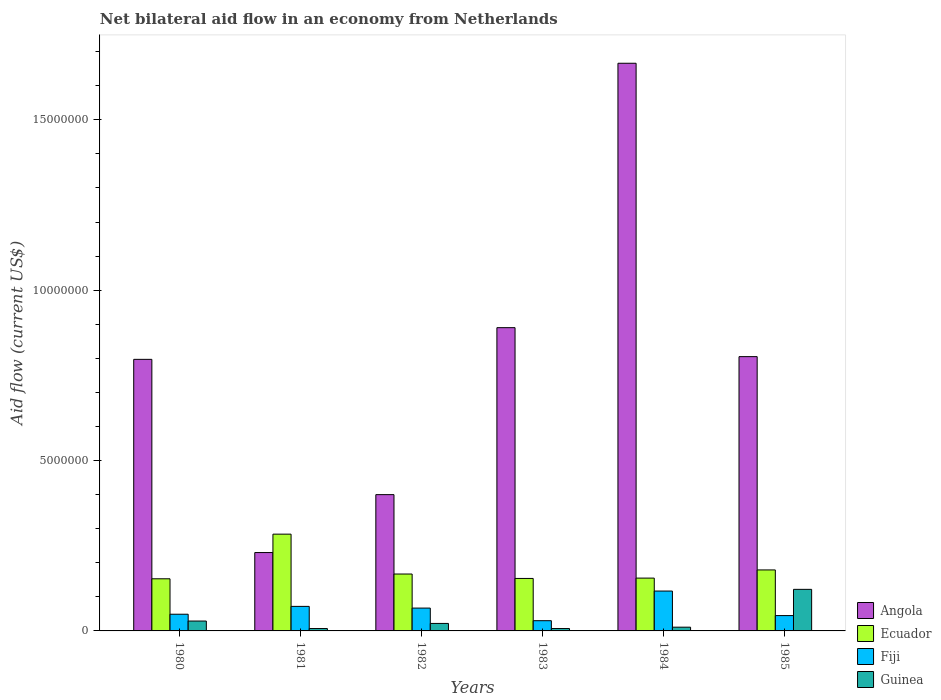Are the number of bars per tick equal to the number of legend labels?
Make the answer very short. Yes. How many bars are there on the 1st tick from the left?
Offer a very short reply. 4. What is the label of the 1st group of bars from the left?
Provide a succinct answer. 1980. Across all years, what is the maximum net bilateral aid flow in Angola?
Offer a terse response. 1.67e+07. Across all years, what is the minimum net bilateral aid flow in Ecuador?
Offer a very short reply. 1.53e+06. In which year was the net bilateral aid flow in Angola maximum?
Offer a terse response. 1984. In which year was the net bilateral aid flow in Angola minimum?
Keep it short and to the point. 1981. What is the total net bilateral aid flow in Fiji in the graph?
Your response must be concise. 3.80e+06. What is the difference between the net bilateral aid flow in Fiji in 1982 and the net bilateral aid flow in Ecuador in 1985?
Offer a very short reply. -1.12e+06. What is the average net bilateral aid flow in Guinea per year?
Ensure brevity in your answer.  3.30e+05. In the year 1980, what is the difference between the net bilateral aid flow in Angola and net bilateral aid flow in Fiji?
Make the answer very short. 7.48e+06. What is the ratio of the net bilateral aid flow in Guinea in 1980 to that in 1985?
Your answer should be compact. 0.24. Is the net bilateral aid flow in Fiji in 1982 less than that in 1985?
Give a very brief answer. No. What is the difference between the highest and the second highest net bilateral aid flow in Guinea?
Give a very brief answer. 9.30e+05. What is the difference between the highest and the lowest net bilateral aid flow in Guinea?
Your response must be concise. 1.15e+06. In how many years, is the net bilateral aid flow in Ecuador greater than the average net bilateral aid flow in Ecuador taken over all years?
Give a very brief answer. 1. Is the sum of the net bilateral aid flow in Guinea in 1982 and 1983 greater than the maximum net bilateral aid flow in Angola across all years?
Keep it short and to the point. No. What does the 3rd bar from the left in 1985 represents?
Give a very brief answer. Fiji. What does the 3rd bar from the right in 1980 represents?
Your response must be concise. Ecuador. Is it the case that in every year, the sum of the net bilateral aid flow in Fiji and net bilateral aid flow in Ecuador is greater than the net bilateral aid flow in Guinea?
Keep it short and to the point. Yes. Are all the bars in the graph horizontal?
Give a very brief answer. No. What is the difference between two consecutive major ticks on the Y-axis?
Make the answer very short. 5.00e+06. How many legend labels are there?
Ensure brevity in your answer.  4. How are the legend labels stacked?
Provide a succinct answer. Vertical. What is the title of the graph?
Offer a terse response. Net bilateral aid flow in an economy from Netherlands. Does "Mongolia" appear as one of the legend labels in the graph?
Keep it short and to the point. No. What is the label or title of the X-axis?
Make the answer very short. Years. What is the Aid flow (current US$) of Angola in 1980?
Give a very brief answer. 7.97e+06. What is the Aid flow (current US$) of Ecuador in 1980?
Offer a terse response. 1.53e+06. What is the Aid flow (current US$) in Fiji in 1980?
Provide a succinct answer. 4.90e+05. What is the Aid flow (current US$) of Guinea in 1980?
Your response must be concise. 2.90e+05. What is the Aid flow (current US$) of Angola in 1981?
Provide a succinct answer. 2.30e+06. What is the Aid flow (current US$) of Ecuador in 1981?
Ensure brevity in your answer.  2.84e+06. What is the Aid flow (current US$) of Fiji in 1981?
Offer a terse response. 7.20e+05. What is the Aid flow (current US$) in Ecuador in 1982?
Give a very brief answer. 1.67e+06. What is the Aid flow (current US$) of Fiji in 1982?
Your answer should be compact. 6.70e+05. What is the Aid flow (current US$) of Angola in 1983?
Provide a short and direct response. 8.90e+06. What is the Aid flow (current US$) of Ecuador in 1983?
Make the answer very short. 1.54e+06. What is the Aid flow (current US$) in Angola in 1984?
Provide a short and direct response. 1.67e+07. What is the Aid flow (current US$) of Ecuador in 1984?
Offer a very short reply. 1.55e+06. What is the Aid flow (current US$) of Fiji in 1984?
Ensure brevity in your answer.  1.17e+06. What is the Aid flow (current US$) in Angola in 1985?
Keep it short and to the point. 8.05e+06. What is the Aid flow (current US$) in Ecuador in 1985?
Offer a very short reply. 1.79e+06. What is the Aid flow (current US$) of Guinea in 1985?
Your answer should be compact. 1.22e+06. Across all years, what is the maximum Aid flow (current US$) in Angola?
Provide a succinct answer. 1.67e+07. Across all years, what is the maximum Aid flow (current US$) in Ecuador?
Offer a very short reply. 2.84e+06. Across all years, what is the maximum Aid flow (current US$) in Fiji?
Your answer should be compact. 1.17e+06. Across all years, what is the maximum Aid flow (current US$) in Guinea?
Ensure brevity in your answer.  1.22e+06. Across all years, what is the minimum Aid flow (current US$) of Angola?
Make the answer very short. 2.30e+06. Across all years, what is the minimum Aid flow (current US$) of Ecuador?
Provide a short and direct response. 1.53e+06. What is the total Aid flow (current US$) in Angola in the graph?
Offer a very short reply. 4.79e+07. What is the total Aid flow (current US$) of Ecuador in the graph?
Ensure brevity in your answer.  1.09e+07. What is the total Aid flow (current US$) of Fiji in the graph?
Keep it short and to the point. 3.80e+06. What is the total Aid flow (current US$) of Guinea in the graph?
Provide a short and direct response. 1.98e+06. What is the difference between the Aid flow (current US$) in Angola in 1980 and that in 1981?
Offer a terse response. 5.67e+06. What is the difference between the Aid flow (current US$) of Ecuador in 1980 and that in 1981?
Provide a short and direct response. -1.31e+06. What is the difference between the Aid flow (current US$) in Angola in 1980 and that in 1982?
Keep it short and to the point. 3.97e+06. What is the difference between the Aid flow (current US$) in Ecuador in 1980 and that in 1982?
Offer a very short reply. -1.40e+05. What is the difference between the Aid flow (current US$) of Fiji in 1980 and that in 1982?
Your answer should be compact. -1.80e+05. What is the difference between the Aid flow (current US$) in Guinea in 1980 and that in 1982?
Keep it short and to the point. 7.00e+04. What is the difference between the Aid flow (current US$) in Angola in 1980 and that in 1983?
Keep it short and to the point. -9.30e+05. What is the difference between the Aid flow (current US$) in Ecuador in 1980 and that in 1983?
Offer a terse response. -10000. What is the difference between the Aid flow (current US$) of Fiji in 1980 and that in 1983?
Offer a very short reply. 1.90e+05. What is the difference between the Aid flow (current US$) of Angola in 1980 and that in 1984?
Offer a very short reply. -8.69e+06. What is the difference between the Aid flow (current US$) in Fiji in 1980 and that in 1984?
Keep it short and to the point. -6.80e+05. What is the difference between the Aid flow (current US$) of Guinea in 1980 and that in 1985?
Keep it short and to the point. -9.30e+05. What is the difference between the Aid flow (current US$) in Angola in 1981 and that in 1982?
Ensure brevity in your answer.  -1.70e+06. What is the difference between the Aid flow (current US$) of Ecuador in 1981 and that in 1982?
Your response must be concise. 1.17e+06. What is the difference between the Aid flow (current US$) in Fiji in 1981 and that in 1982?
Ensure brevity in your answer.  5.00e+04. What is the difference between the Aid flow (current US$) of Guinea in 1981 and that in 1982?
Keep it short and to the point. -1.50e+05. What is the difference between the Aid flow (current US$) of Angola in 1981 and that in 1983?
Provide a short and direct response. -6.60e+06. What is the difference between the Aid flow (current US$) of Ecuador in 1981 and that in 1983?
Your answer should be compact. 1.30e+06. What is the difference between the Aid flow (current US$) in Guinea in 1981 and that in 1983?
Your response must be concise. 0. What is the difference between the Aid flow (current US$) of Angola in 1981 and that in 1984?
Offer a very short reply. -1.44e+07. What is the difference between the Aid flow (current US$) of Ecuador in 1981 and that in 1984?
Your answer should be very brief. 1.29e+06. What is the difference between the Aid flow (current US$) of Fiji in 1981 and that in 1984?
Your answer should be compact. -4.50e+05. What is the difference between the Aid flow (current US$) of Guinea in 1981 and that in 1984?
Provide a short and direct response. -4.00e+04. What is the difference between the Aid flow (current US$) of Angola in 1981 and that in 1985?
Offer a very short reply. -5.75e+06. What is the difference between the Aid flow (current US$) in Ecuador in 1981 and that in 1985?
Make the answer very short. 1.05e+06. What is the difference between the Aid flow (current US$) in Fiji in 1981 and that in 1985?
Ensure brevity in your answer.  2.70e+05. What is the difference between the Aid flow (current US$) of Guinea in 1981 and that in 1985?
Ensure brevity in your answer.  -1.15e+06. What is the difference between the Aid flow (current US$) of Angola in 1982 and that in 1983?
Your answer should be compact. -4.90e+06. What is the difference between the Aid flow (current US$) in Angola in 1982 and that in 1984?
Offer a very short reply. -1.27e+07. What is the difference between the Aid flow (current US$) in Ecuador in 1982 and that in 1984?
Your answer should be very brief. 1.20e+05. What is the difference between the Aid flow (current US$) of Fiji in 1982 and that in 1984?
Offer a terse response. -5.00e+05. What is the difference between the Aid flow (current US$) in Guinea in 1982 and that in 1984?
Keep it short and to the point. 1.10e+05. What is the difference between the Aid flow (current US$) of Angola in 1982 and that in 1985?
Provide a succinct answer. -4.05e+06. What is the difference between the Aid flow (current US$) in Ecuador in 1982 and that in 1985?
Offer a very short reply. -1.20e+05. What is the difference between the Aid flow (current US$) of Fiji in 1982 and that in 1985?
Your answer should be very brief. 2.20e+05. What is the difference between the Aid flow (current US$) of Guinea in 1982 and that in 1985?
Your answer should be compact. -1.00e+06. What is the difference between the Aid flow (current US$) in Angola in 1983 and that in 1984?
Give a very brief answer. -7.76e+06. What is the difference between the Aid flow (current US$) in Ecuador in 1983 and that in 1984?
Provide a short and direct response. -10000. What is the difference between the Aid flow (current US$) in Fiji in 1983 and that in 1984?
Keep it short and to the point. -8.70e+05. What is the difference between the Aid flow (current US$) in Angola in 1983 and that in 1985?
Offer a very short reply. 8.50e+05. What is the difference between the Aid flow (current US$) of Ecuador in 1983 and that in 1985?
Keep it short and to the point. -2.50e+05. What is the difference between the Aid flow (current US$) in Guinea in 1983 and that in 1985?
Offer a terse response. -1.15e+06. What is the difference between the Aid flow (current US$) of Angola in 1984 and that in 1985?
Your answer should be very brief. 8.61e+06. What is the difference between the Aid flow (current US$) of Fiji in 1984 and that in 1985?
Ensure brevity in your answer.  7.20e+05. What is the difference between the Aid flow (current US$) in Guinea in 1984 and that in 1985?
Your response must be concise. -1.11e+06. What is the difference between the Aid flow (current US$) of Angola in 1980 and the Aid flow (current US$) of Ecuador in 1981?
Provide a short and direct response. 5.13e+06. What is the difference between the Aid flow (current US$) in Angola in 1980 and the Aid flow (current US$) in Fiji in 1981?
Make the answer very short. 7.25e+06. What is the difference between the Aid flow (current US$) of Angola in 1980 and the Aid flow (current US$) of Guinea in 1981?
Make the answer very short. 7.90e+06. What is the difference between the Aid flow (current US$) of Ecuador in 1980 and the Aid flow (current US$) of Fiji in 1981?
Your response must be concise. 8.10e+05. What is the difference between the Aid flow (current US$) in Ecuador in 1980 and the Aid flow (current US$) in Guinea in 1981?
Ensure brevity in your answer.  1.46e+06. What is the difference between the Aid flow (current US$) of Fiji in 1980 and the Aid flow (current US$) of Guinea in 1981?
Offer a terse response. 4.20e+05. What is the difference between the Aid flow (current US$) in Angola in 1980 and the Aid flow (current US$) in Ecuador in 1982?
Provide a succinct answer. 6.30e+06. What is the difference between the Aid flow (current US$) in Angola in 1980 and the Aid flow (current US$) in Fiji in 1982?
Provide a short and direct response. 7.30e+06. What is the difference between the Aid flow (current US$) of Angola in 1980 and the Aid flow (current US$) of Guinea in 1982?
Offer a terse response. 7.75e+06. What is the difference between the Aid flow (current US$) in Ecuador in 1980 and the Aid flow (current US$) in Fiji in 1982?
Offer a very short reply. 8.60e+05. What is the difference between the Aid flow (current US$) in Ecuador in 1980 and the Aid flow (current US$) in Guinea in 1982?
Offer a terse response. 1.31e+06. What is the difference between the Aid flow (current US$) of Fiji in 1980 and the Aid flow (current US$) of Guinea in 1982?
Keep it short and to the point. 2.70e+05. What is the difference between the Aid flow (current US$) of Angola in 1980 and the Aid flow (current US$) of Ecuador in 1983?
Make the answer very short. 6.43e+06. What is the difference between the Aid flow (current US$) of Angola in 1980 and the Aid flow (current US$) of Fiji in 1983?
Offer a terse response. 7.67e+06. What is the difference between the Aid flow (current US$) in Angola in 1980 and the Aid flow (current US$) in Guinea in 1983?
Keep it short and to the point. 7.90e+06. What is the difference between the Aid flow (current US$) in Ecuador in 1980 and the Aid flow (current US$) in Fiji in 1983?
Make the answer very short. 1.23e+06. What is the difference between the Aid flow (current US$) in Ecuador in 1980 and the Aid flow (current US$) in Guinea in 1983?
Your response must be concise. 1.46e+06. What is the difference between the Aid flow (current US$) of Angola in 1980 and the Aid flow (current US$) of Ecuador in 1984?
Provide a short and direct response. 6.42e+06. What is the difference between the Aid flow (current US$) of Angola in 1980 and the Aid flow (current US$) of Fiji in 1984?
Your response must be concise. 6.80e+06. What is the difference between the Aid flow (current US$) in Angola in 1980 and the Aid flow (current US$) in Guinea in 1984?
Your answer should be compact. 7.86e+06. What is the difference between the Aid flow (current US$) in Ecuador in 1980 and the Aid flow (current US$) in Guinea in 1984?
Make the answer very short. 1.42e+06. What is the difference between the Aid flow (current US$) of Angola in 1980 and the Aid flow (current US$) of Ecuador in 1985?
Keep it short and to the point. 6.18e+06. What is the difference between the Aid flow (current US$) of Angola in 1980 and the Aid flow (current US$) of Fiji in 1985?
Ensure brevity in your answer.  7.52e+06. What is the difference between the Aid flow (current US$) of Angola in 1980 and the Aid flow (current US$) of Guinea in 1985?
Keep it short and to the point. 6.75e+06. What is the difference between the Aid flow (current US$) of Ecuador in 1980 and the Aid flow (current US$) of Fiji in 1985?
Make the answer very short. 1.08e+06. What is the difference between the Aid flow (current US$) in Ecuador in 1980 and the Aid flow (current US$) in Guinea in 1985?
Your response must be concise. 3.10e+05. What is the difference between the Aid flow (current US$) of Fiji in 1980 and the Aid flow (current US$) of Guinea in 1985?
Offer a very short reply. -7.30e+05. What is the difference between the Aid flow (current US$) in Angola in 1981 and the Aid flow (current US$) in Ecuador in 1982?
Your answer should be very brief. 6.30e+05. What is the difference between the Aid flow (current US$) of Angola in 1981 and the Aid flow (current US$) of Fiji in 1982?
Keep it short and to the point. 1.63e+06. What is the difference between the Aid flow (current US$) in Angola in 1981 and the Aid flow (current US$) in Guinea in 1982?
Provide a succinct answer. 2.08e+06. What is the difference between the Aid flow (current US$) in Ecuador in 1981 and the Aid flow (current US$) in Fiji in 1982?
Your response must be concise. 2.17e+06. What is the difference between the Aid flow (current US$) of Ecuador in 1981 and the Aid flow (current US$) of Guinea in 1982?
Provide a succinct answer. 2.62e+06. What is the difference between the Aid flow (current US$) of Angola in 1981 and the Aid flow (current US$) of Ecuador in 1983?
Give a very brief answer. 7.60e+05. What is the difference between the Aid flow (current US$) in Angola in 1981 and the Aid flow (current US$) in Fiji in 1983?
Your response must be concise. 2.00e+06. What is the difference between the Aid flow (current US$) of Angola in 1981 and the Aid flow (current US$) of Guinea in 1983?
Your answer should be compact. 2.23e+06. What is the difference between the Aid flow (current US$) of Ecuador in 1981 and the Aid flow (current US$) of Fiji in 1983?
Keep it short and to the point. 2.54e+06. What is the difference between the Aid flow (current US$) of Ecuador in 1981 and the Aid flow (current US$) of Guinea in 1983?
Your answer should be compact. 2.77e+06. What is the difference between the Aid flow (current US$) of Fiji in 1981 and the Aid flow (current US$) of Guinea in 1983?
Make the answer very short. 6.50e+05. What is the difference between the Aid flow (current US$) of Angola in 1981 and the Aid flow (current US$) of Ecuador in 1984?
Keep it short and to the point. 7.50e+05. What is the difference between the Aid flow (current US$) of Angola in 1981 and the Aid flow (current US$) of Fiji in 1984?
Ensure brevity in your answer.  1.13e+06. What is the difference between the Aid flow (current US$) in Angola in 1981 and the Aid flow (current US$) in Guinea in 1984?
Offer a terse response. 2.19e+06. What is the difference between the Aid flow (current US$) of Ecuador in 1981 and the Aid flow (current US$) of Fiji in 1984?
Your answer should be very brief. 1.67e+06. What is the difference between the Aid flow (current US$) of Ecuador in 1981 and the Aid flow (current US$) of Guinea in 1984?
Make the answer very short. 2.73e+06. What is the difference between the Aid flow (current US$) in Angola in 1981 and the Aid flow (current US$) in Ecuador in 1985?
Offer a terse response. 5.10e+05. What is the difference between the Aid flow (current US$) in Angola in 1981 and the Aid flow (current US$) in Fiji in 1985?
Offer a terse response. 1.85e+06. What is the difference between the Aid flow (current US$) in Angola in 1981 and the Aid flow (current US$) in Guinea in 1985?
Provide a short and direct response. 1.08e+06. What is the difference between the Aid flow (current US$) of Ecuador in 1981 and the Aid flow (current US$) of Fiji in 1985?
Your answer should be very brief. 2.39e+06. What is the difference between the Aid flow (current US$) of Ecuador in 1981 and the Aid flow (current US$) of Guinea in 1985?
Offer a terse response. 1.62e+06. What is the difference between the Aid flow (current US$) in Fiji in 1981 and the Aid flow (current US$) in Guinea in 1985?
Offer a very short reply. -5.00e+05. What is the difference between the Aid flow (current US$) in Angola in 1982 and the Aid flow (current US$) in Ecuador in 1983?
Give a very brief answer. 2.46e+06. What is the difference between the Aid flow (current US$) in Angola in 1982 and the Aid flow (current US$) in Fiji in 1983?
Offer a terse response. 3.70e+06. What is the difference between the Aid flow (current US$) in Angola in 1982 and the Aid flow (current US$) in Guinea in 1983?
Your answer should be very brief. 3.93e+06. What is the difference between the Aid flow (current US$) of Ecuador in 1982 and the Aid flow (current US$) of Fiji in 1983?
Make the answer very short. 1.37e+06. What is the difference between the Aid flow (current US$) of Ecuador in 1982 and the Aid flow (current US$) of Guinea in 1983?
Provide a short and direct response. 1.60e+06. What is the difference between the Aid flow (current US$) in Angola in 1982 and the Aid flow (current US$) in Ecuador in 1984?
Provide a succinct answer. 2.45e+06. What is the difference between the Aid flow (current US$) in Angola in 1982 and the Aid flow (current US$) in Fiji in 1984?
Provide a succinct answer. 2.83e+06. What is the difference between the Aid flow (current US$) in Angola in 1982 and the Aid flow (current US$) in Guinea in 1984?
Provide a succinct answer. 3.89e+06. What is the difference between the Aid flow (current US$) of Ecuador in 1982 and the Aid flow (current US$) of Guinea in 1984?
Give a very brief answer. 1.56e+06. What is the difference between the Aid flow (current US$) of Fiji in 1982 and the Aid flow (current US$) of Guinea in 1984?
Ensure brevity in your answer.  5.60e+05. What is the difference between the Aid flow (current US$) of Angola in 1982 and the Aid flow (current US$) of Ecuador in 1985?
Provide a succinct answer. 2.21e+06. What is the difference between the Aid flow (current US$) in Angola in 1982 and the Aid flow (current US$) in Fiji in 1985?
Ensure brevity in your answer.  3.55e+06. What is the difference between the Aid flow (current US$) in Angola in 1982 and the Aid flow (current US$) in Guinea in 1985?
Keep it short and to the point. 2.78e+06. What is the difference between the Aid flow (current US$) in Ecuador in 1982 and the Aid flow (current US$) in Fiji in 1985?
Offer a very short reply. 1.22e+06. What is the difference between the Aid flow (current US$) of Ecuador in 1982 and the Aid flow (current US$) of Guinea in 1985?
Offer a very short reply. 4.50e+05. What is the difference between the Aid flow (current US$) in Fiji in 1982 and the Aid flow (current US$) in Guinea in 1985?
Provide a succinct answer. -5.50e+05. What is the difference between the Aid flow (current US$) of Angola in 1983 and the Aid flow (current US$) of Ecuador in 1984?
Offer a very short reply. 7.35e+06. What is the difference between the Aid flow (current US$) in Angola in 1983 and the Aid flow (current US$) in Fiji in 1984?
Give a very brief answer. 7.73e+06. What is the difference between the Aid flow (current US$) of Angola in 1983 and the Aid flow (current US$) of Guinea in 1984?
Your response must be concise. 8.79e+06. What is the difference between the Aid flow (current US$) in Ecuador in 1983 and the Aid flow (current US$) in Fiji in 1984?
Your response must be concise. 3.70e+05. What is the difference between the Aid flow (current US$) of Ecuador in 1983 and the Aid flow (current US$) of Guinea in 1984?
Provide a succinct answer. 1.43e+06. What is the difference between the Aid flow (current US$) of Angola in 1983 and the Aid flow (current US$) of Ecuador in 1985?
Keep it short and to the point. 7.11e+06. What is the difference between the Aid flow (current US$) of Angola in 1983 and the Aid flow (current US$) of Fiji in 1985?
Offer a terse response. 8.45e+06. What is the difference between the Aid flow (current US$) of Angola in 1983 and the Aid flow (current US$) of Guinea in 1985?
Your response must be concise. 7.68e+06. What is the difference between the Aid flow (current US$) of Ecuador in 1983 and the Aid flow (current US$) of Fiji in 1985?
Give a very brief answer. 1.09e+06. What is the difference between the Aid flow (current US$) in Fiji in 1983 and the Aid flow (current US$) in Guinea in 1985?
Provide a short and direct response. -9.20e+05. What is the difference between the Aid flow (current US$) of Angola in 1984 and the Aid flow (current US$) of Ecuador in 1985?
Your answer should be very brief. 1.49e+07. What is the difference between the Aid flow (current US$) in Angola in 1984 and the Aid flow (current US$) in Fiji in 1985?
Make the answer very short. 1.62e+07. What is the difference between the Aid flow (current US$) in Angola in 1984 and the Aid flow (current US$) in Guinea in 1985?
Your answer should be compact. 1.54e+07. What is the difference between the Aid flow (current US$) in Ecuador in 1984 and the Aid flow (current US$) in Fiji in 1985?
Provide a succinct answer. 1.10e+06. What is the average Aid flow (current US$) of Angola per year?
Offer a terse response. 7.98e+06. What is the average Aid flow (current US$) of Ecuador per year?
Make the answer very short. 1.82e+06. What is the average Aid flow (current US$) of Fiji per year?
Make the answer very short. 6.33e+05. In the year 1980, what is the difference between the Aid flow (current US$) of Angola and Aid flow (current US$) of Ecuador?
Your answer should be compact. 6.44e+06. In the year 1980, what is the difference between the Aid flow (current US$) of Angola and Aid flow (current US$) of Fiji?
Ensure brevity in your answer.  7.48e+06. In the year 1980, what is the difference between the Aid flow (current US$) in Angola and Aid flow (current US$) in Guinea?
Make the answer very short. 7.68e+06. In the year 1980, what is the difference between the Aid flow (current US$) in Ecuador and Aid flow (current US$) in Fiji?
Provide a succinct answer. 1.04e+06. In the year 1980, what is the difference between the Aid flow (current US$) in Ecuador and Aid flow (current US$) in Guinea?
Give a very brief answer. 1.24e+06. In the year 1980, what is the difference between the Aid flow (current US$) in Fiji and Aid flow (current US$) in Guinea?
Keep it short and to the point. 2.00e+05. In the year 1981, what is the difference between the Aid flow (current US$) in Angola and Aid flow (current US$) in Ecuador?
Give a very brief answer. -5.40e+05. In the year 1981, what is the difference between the Aid flow (current US$) in Angola and Aid flow (current US$) in Fiji?
Your response must be concise. 1.58e+06. In the year 1981, what is the difference between the Aid flow (current US$) of Angola and Aid flow (current US$) of Guinea?
Offer a very short reply. 2.23e+06. In the year 1981, what is the difference between the Aid flow (current US$) of Ecuador and Aid flow (current US$) of Fiji?
Your answer should be compact. 2.12e+06. In the year 1981, what is the difference between the Aid flow (current US$) of Ecuador and Aid flow (current US$) of Guinea?
Your response must be concise. 2.77e+06. In the year 1981, what is the difference between the Aid flow (current US$) of Fiji and Aid flow (current US$) of Guinea?
Give a very brief answer. 6.50e+05. In the year 1982, what is the difference between the Aid flow (current US$) of Angola and Aid flow (current US$) of Ecuador?
Give a very brief answer. 2.33e+06. In the year 1982, what is the difference between the Aid flow (current US$) of Angola and Aid flow (current US$) of Fiji?
Your response must be concise. 3.33e+06. In the year 1982, what is the difference between the Aid flow (current US$) of Angola and Aid flow (current US$) of Guinea?
Ensure brevity in your answer.  3.78e+06. In the year 1982, what is the difference between the Aid flow (current US$) of Ecuador and Aid flow (current US$) of Guinea?
Provide a short and direct response. 1.45e+06. In the year 1983, what is the difference between the Aid flow (current US$) of Angola and Aid flow (current US$) of Ecuador?
Provide a succinct answer. 7.36e+06. In the year 1983, what is the difference between the Aid flow (current US$) in Angola and Aid flow (current US$) in Fiji?
Give a very brief answer. 8.60e+06. In the year 1983, what is the difference between the Aid flow (current US$) of Angola and Aid flow (current US$) of Guinea?
Offer a very short reply. 8.83e+06. In the year 1983, what is the difference between the Aid flow (current US$) of Ecuador and Aid flow (current US$) of Fiji?
Your answer should be very brief. 1.24e+06. In the year 1983, what is the difference between the Aid flow (current US$) in Ecuador and Aid flow (current US$) in Guinea?
Give a very brief answer. 1.47e+06. In the year 1984, what is the difference between the Aid flow (current US$) in Angola and Aid flow (current US$) in Ecuador?
Offer a very short reply. 1.51e+07. In the year 1984, what is the difference between the Aid flow (current US$) in Angola and Aid flow (current US$) in Fiji?
Keep it short and to the point. 1.55e+07. In the year 1984, what is the difference between the Aid flow (current US$) in Angola and Aid flow (current US$) in Guinea?
Your response must be concise. 1.66e+07. In the year 1984, what is the difference between the Aid flow (current US$) of Ecuador and Aid flow (current US$) of Fiji?
Provide a short and direct response. 3.80e+05. In the year 1984, what is the difference between the Aid flow (current US$) in Ecuador and Aid flow (current US$) in Guinea?
Ensure brevity in your answer.  1.44e+06. In the year 1984, what is the difference between the Aid flow (current US$) of Fiji and Aid flow (current US$) of Guinea?
Offer a terse response. 1.06e+06. In the year 1985, what is the difference between the Aid flow (current US$) of Angola and Aid flow (current US$) of Ecuador?
Offer a terse response. 6.26e+06. In the year 1985, what is the difference between the Aid flow (current US$) in Angola and Aid flow (current US$) in Fiji?
Give a very brief answer. 7.60e+06. In the year 1985, what is the difference between the Aid flow (current US$) of Angola and Aid flow (current US$) of Guinea?
Your answer should be compact. 6.83e+06. In the year 1985, what is the difference between the Aid flow (current US$) in Ecuador and Aid flow (current US$) in Fiji?
Your answer should be compact. 1.34e+06. In the year 1985, what is the difference between the Aid flow (current US$) in Ecuador and Aid flow (current US$) in Guinea?
Give a very brief answer. 5.70e+05. In the year 1985, what is the difference between the Aid flow (current US$) in Fiji and Aid flow (current US$) in Guinea?
Make the answer very short. -7.70e+05. What is the ratio of the Aid flow (current US$) in Angola in 1980 to that in 1981?
Ensure brevity in your answer.  3.47. What is the ratio of the Aid flow (current US$) of Ecuador in 1980 to that in 1981?
Your response must be concise. 0.54. What is the ratio of the Aid flow (current US$) of Fiji in 1980 to that in 1981?
Give a very brief answer. 0.68. What is the ratio of the Aid flow (current US$) in Guinea in 1980 to that in 1981?
Give a very brief answer. 4.14. What is the ratio of the Aid flow (current US$) of Angola in 1980 to that in 1982?
Your answer should be compact. 1.99. What is the ratio of the Aid flow (current US$) in Ecuador in 1980 to that in 1982?
Provide a short and direct response. 0.92. What is the ratio of the Aid flow (current US$) in Fiji in 1980 to that in 1982?
Your response must be concise. 0.73. What is the ratio of the Aid flow (current US$) of Guinea in 1980 to that in 1982?
Give a very brief answer. 1.32. What is the ratio of the Aid flow (current US$) in Angola in 1980 to that in 1983?
Ensure brevity in your answer.  0.9. What is the ratio of the Aid flow (current US$) of Fiji in 1980 to that in 1983?
Make the answer very short. 1.63. What is the ratio of the Aid flow (current US$) of Guinea in 1980 to that in 1983?
Provide a short and direct response. 4.14. What is the ratio of the Aid flow (current US$) of Angola in 1980 to that in 1984?
Give a very brief answer. 0.48. What is the ratio of the Aid flow (current US$) of Ecuador in 1980 to that in 1984?
Your response must be concise. 0.99. What is the ratio of the Aid flow (current US$) in Fiji in 1980 to that in 1984?
Your response must be concise. 0.42. What is the ratio of the Aid flow (current US$) of Guinea in 1980 to that in 1984?
Your answer should be compact. 2.64. What is the ratio of the Aid flow (current US$) in Ecuador in 1980 to that in 1985?
Your response must be concise. 0.85. What is the ratio of the Aid flow (current US$) in Fiji in 1980 to that in 1985?
Give a very brief answer. 1.09. What is the ratio of the Aid flow (current US$) of Guinea in 1980 to that in 1985?
Your answer should be compact. 0.24. What is the ratio of the Aid flow (current US$) of Angola in 1981 to that in 1982?
Provide a succinct answer. 0.57. What is the ratio of the Aid flow (current US$) of Ecuador in 1981 to that in 1982?
Ensure brevity in your answer.  1.7. What is the ratio of the Aid flow (current US$) of Fiji in 1981 to that in 1982?
Your answer should be very brief. 1.07. What is the ratio of the Aid flow (current US$) in Guinea in 1981 to that in 1982?
Make the answer very short. 0.32. What is the ratio of the Aid flow (current US$) of Angola in 1981 to that in 1983?
Your response must be concise. 0.26. What is the ratio of the Aid flow (current US$) in Ecuador in 1981 to that in 1983?
Ensure brevity in your answer.  1.84. What is the ratio of the Aid flow (current US$) in Fiji in 1981 to that in 1983?
Give a very brief answer. 2.4. What is the ratio of the Aid flow (current US$) of Angola in 1981 to that in 1984?
Give a very brief answer. 0.14. What is the ratio of the Aid flow (current US$) in Ecuador in 1981 to that in 1984?
Give a very brief answer. 1.83. What is the ratio of the Aid flow (current US$) in Fiji in 1981 to that in 1984?
Your answer should be compact. 0.62. What is the ratio of the Aid flow (current US$) in Guinea in 1981 to that in 1984?
Ensure brevity in your answer.  0.64. What is the ratio of the Aid flow (current US$) of Angola in 1981 to that in 1985?
Make the answer very short. 0.29. What is the ratio of the Aid flow (current US$) of Ecuador in 1981 to that in 1985?
Make the answer very short. 1.59. What is the ratio of the Aid flow (current US$) of Fiji in 1981 to that in 1985?
Your answer should be very brief. 1.6. What is the ratio of the Aid flow (current US$) of Guinea in 1981 to that in 1985?
Provide a succinct answer. 0.06. What is the ratio of the Aid flow (current US$) of Angola in 1982 to that in 1983?
Provide a short and direct response. 0.45. What is the ratio of the Aid flow (current US$) in Ecuador in 1982 to that in 1983?
Give a very brief answer. 1.08. What is the ratio of the Aid flow (current US$) in Fiji in 1982 to that in 1983?
Offer a very short reply. 2.23. What is the ratio of the Aid flow (current US$) of Guinea in 1982 to that in 1983?
Your answer should be very brief. 3.14. What is the ratio of the Aid flow (current US$) in Angola in 1982 to that in 1984?
Keep it short and to the point. 0.24. What is the ratio of the Aid flow (current US$) of Ecuador in 1982 to that in 1984?
Give a very brief answer. 1.08. What is the ratio of the Aid flow (current US$) in Fiji in 1982 to that in 1984?
Provide a short and direct response. 0.57. What is the ratio of the Aid flow (current US$) in Guinea in 1982 to that in 1984?
Your answer should be very brief. 2. What is the ratio of the Aid flow (current US$) of Angola in 1982 to that in 1985?
Your answer should be compact. 0.5. What is the ratio of the Aid flow (current US$) in Ecuador in 1982 to that in 1985?
Give a very brief answer. 0.93. What is the ratio of the Aid flow (current US$) of Fiji in 1982 to that in 1985?
Provide a short and direct response. 1.49. What is the ratio of the Aid flow (current US$) in Guinea in 1982 to that in 1985?
Make the answer very short. 0.18. What is the ratio of the Aid flow (current US$) in Angola in 1983 to that in 1984?
Provide a short and direct response. 0.53. What is the ratio of the Aid flow (current US$) in Ecuador in 1983 to that in 1984?
Ensure brevity in your answer.  0.99. What is the ratio of the Aid flow (current US$) of Fiji in 1983 to that in 1984?
Offer a very short reply. 0.26. What is the ratio of the Aid flow (current US$) of Guinea in 1983 to that in 1984?
Make the answer very short. 0.64. What is the ratio of the Aid flow (current US$) in Angola in 1983 to that in 1985?
Provide a succinct answer. 1.11. What is the ratio of the Aid flow (current US$) in Ecuador in 1983 to that in 1985?
Provide a short and direct response. 0.86. What is the ratio of the Aid flow (current US$) of Fiji in 1983 to that in 1985?
Provide a succinct answer. 0.67. What is the ratio of the Aid flow (current US$) in Guinea in 1983 to that in 1985?
Provide a succinct answer. 0.06. What is the ratio of the Aid flow (current US$) of Angola in 1984 to that in 1985?
Ensure brevity in your answer.  2.07. What is the ratio of the Aid flow (current US$) of Ecuador in 1984 to that in 1985?
Your answer should be very brief. 0.87. What is the ratio of the Aid flow (current US$) of Guinea in 1984 to that in 1985?
Your response must be concise. 0.09. What is the difference between the highest and the second highest Aid flow (current US$) of Angola?
Give a very brief answer. 7.76e+06. What is the difference between the highest and the second highest Aid flow (current US$) of Ecuador?
Your answer should be compact. 1.05e+06. What is the difference between the highest and the second highest Aid flow (current US$) of Guinea?
Ensure brevity in your answer.  9.30e+05. What is the difference between the highest and the lowest Aid flow (current US$) of Angola?
Your answer should be compact. 1.44e+07. What is the difference between the highest and the lowest Aid flow (current US$) of Ecuador?
Offer a very short reply. 1.31e+06. What is the difference between the highest and the lowest Aid flow (current US$) in Fiji?
Ensure brevity in your answer.  8.70e+05. What is the difference between the highest and the lowest Aid flow (current US$) of Guinea?
Give a very brief answer. 1.15e+06. 